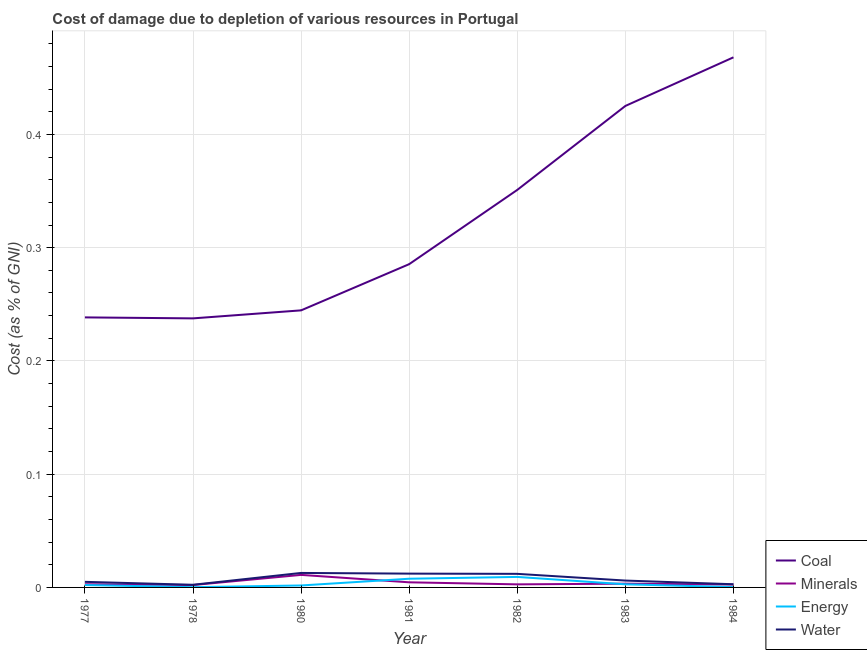How many different coloured lines are there?
Your response must be concise. 4. Does the line corresponding to cost of damage due to depletion of coal intersect with the line corresponding to cost of damage due to depletion of water?
Your answer should be very brief. No. What is the cost of damage due to depletion of minerals in 1983?
Ensure brevity in your answer.  0. Across all years, what is the maximum cost of damage due to depletion of energy?
Give a very brief answer. 0.01. Across all years, what is the minimum cost of damage due to depletion of water?
Offer a very short reply. 0. In which year was the cost of damage due to depletion of minerals minimum?
Provide a short and direct response. 1978. What is the total cost of damage due to depletion of minerals in the graph?
Your answer should be very brief. 0.03. What is the difference between the cost of damage due to depletion of coal in 1980 and that in 1981?
Ensure brevity in your answer.  -0.04. What is the difference between the cost of damage due to depletion of water in 1984 and the cost of damage due to depletion of energy in 1983?
Give a very brief answer. 5.863535926893017e-5. What is the average cost of damage due to depletion of energy per year?
Offer a very short reply. 0. In the year 1982, what is the difference between the cost of damage due to depletion of water and cost of damage due to depletion of minerals?
Ensure brevity in your answer.  0.01. In how many years, is the cost of damage due to depletion of coal greater than 0.22 %?
Keep it short and to the point. 7. What is the ratio of the cost of damage due to depletion of minerals in 1982 to that in 1984?
Your answer should be compact. 1.07. Is the difference between the cost of damage due to depletion of minerals in 1982 and 1984 greater than the difference between the cost of damage due to depletion of water in 1982 and 1984?
Provide a short and direct response. No. What is the difference between the highest and the second highest cost of damage due to depletion of minerals?
Provide a succinct answer. 0.01. What is the difference between the highest and the lowest cost of damage due to depletion of minerals?
Your answer should be compact. 0.01. Is it the case that in every year, the sum of the cost of damage due to depletion of coal and cost of damage due to depletion of minerals is greater than the cost of damage due to depletion of energy?
Make the answer very short. Yes. Does the cost of damage due to depletion of coal monotonically increase over the years?
Give a very brief answer. No. What is the difference between two consecutive major ticks on the Y-axis?
Provide a succinct answer. 0.1. Are the values on the major ticks of Y-axis written in scientific E-notation?
Your answer should be very brief. No. Does the graph contain any zero values?
Offer a very short reply. No. Where does the legend appear in the graph?
Ensure brevity in your answer.  Bottom right. What is the title of the graph?
Offer a very short reply. Cost of damage due to depletion of various resources in Portugal . What is the label or title of the Y-axis?
Ensure brevity in your answer.  Cost (as % of GNI). What is the Cost (as % of GNI) in Coal in 1977?
Ensure brevity in your answer.  0.24. What is the Cost (as % of GNI) in Minerals in 1977?
Your answer should be compact. 0. What is the Cost (as % of GNI) of Energy in 1977?
Your answer should be compact. 0. What is the Cost (as % of GNI) in Water in 1977?
Your answer should be compact. 0. What is the Cost (as % of GNI) in Coal in 1978?
Your response must be concise. 0.24. What is the Cost (as % of GNI) of Minerals in 1978?
Your answer should be very brief. 0. What is the Cost (as % of GNI) of Energy in 1978?
Provide a succinct answer. 0. What is the Cost (as % of GNI) of Water in 1978?
Provide a short and direct response. 0. What is the Cost (as % of GNI) in Coal in 1980?
Give a very brief answer. 0.24. What is the Cost (as % of GNI) in Minerals in 1980?
Provide a short and direct response. 0.01. What is the Cost (as % of GNI) in Energy in 1980?
Your answer should be very brief. 0. What is the Cost (as % of GNI) in Water in 1980?
Give a very brief answer. 0.01. What is the Cost (as % of GNI) of Coal in 1981?
Make the answer very short. 0.29. What is the Cost (as % of GNI) of Minerals in 1981?
Your answer should be very brief. 0. What is the Cost (as % of GNI) of Energy in 1981?
Your answer should be very brief. 0.01. What is the Cost (as % of GNI) in Water in 1981?
Offer a terse response. 0.01. What is the Cost (as % of GNI) of Coal in 1982?
Provide a short and direct response. 0.35. What is the Cost (as % of GNI) in Minerals in 1982?
Your response must be concise. 0. What is the Cost (as % of GNI) of Energy in 1982?
Give a very brief answer. 0.01. What is the Cost (as % of GNI) of Water in 1982?
Your answer should be compact. 0.01. What is the Cost (as % of GNI) in Coal in 1983?
Make the answer very short. 0.43. What is the Cost (as % of GNI) of Minerals in 1983?
Provide a short and direct response. 0. What is the Cost (as % of GNI) in Energy in 1983?
Provide a succinct answer. 0. What is the Cost (as % of GNI) in Water in 1983?
Offer a terse response. 0.01. What is the Cost (as % of GNI) in Coal in 1984?
Your answer should be compact. 0.47. What is the Cost (as % of GNI) in Minerals in 1984?
Your answer should be compact. 0. What is the Cost (as % of GNI) of Energy in 1984?
Your answer should be very brief. 0. What is the Cost (as % of GNI) in Water in 1984?
Keep it short and to the point. 0. Across all years, what is the maximum Cost (as % of GNI) of Coal?
Your answer should be compact. 0.47. Across all years, what is the maximum Cost (as % of GNI) of Minerals?
Provide a succinct answer. 0.01. Across all years, what is the maximum Cost (as % of GNI) in Energy?
Provide a succinct answer. 0.01. Across all years, what is the maximum Cost (as % of GNI) in Water?
Provide a short and direct response. 0.01. Across all years, what is the minimum Cost (as % of GNI) of Coal?
Make the answer very short. 0.24. Across all years, what is the minimum Cost (as % of GNI) in Minerals?
Offer a terse response. 0. Across all years, what is the minimum Cost (as % of GNI) in Energy?
Make the answer very short. 0. Across all years, what is the minimum Cost (as % of GNI) of Water?
Provide a succinct answer. 0. What is the total Cost (as % of GNI) of Coal in the graph?
Keep it short and to the point. 2.25. What is the total Cost (as % of GNI) in Minerals in the graph?
Keep it short and to the point. 0.03. What is the total Cost (as % of GNI) in Energy in the graph?
Your response must be concise. 0.02. What is the total Cost (as % of GNI) of Water in the graph?
Offer a very short reply. 0.05. What is the difference between the Cost (as % of GNI) in Coal in 1977 and that in 1978?
Your response must be concise. 0. What is the difference between the Cost (as % of GNI) of Minerals in 1977 and that in 1978?
Keep it short and to the point. 0. What is the difference between the Cost (as % of GNI) of Energy in 1977 and that in 1978?
Your answer should be very brief. 0. What is the difference between the Cost (as % of GNI) in Water in 1977 and that in 1978?
Give a very brief answer. 0. What is the difference between the Cost (as % of GNI) of Coal in 1977 and that in 1980?
Your answer should be very brief. -0.01. What is the difference between the Cost (as % of GNI) of Minerals in 1977 and that in 1980?
Your answer should be compact. -0.01. What is the difference between the Cost (as % of GNI) in Energy in 1977 and that in 1980?
Ensure brevity in your answer.  0. What is the difference between the Cost (as % of GNI) of Water in 1977 and that in 1980?
Your response must be concise. -0.01. What is the difference between the Cost (as % of GNI) in Coal in 1977 and that in 1981?
Make the answer very short. -0.05. What is the difference between the Cost (as % of GNI) in Minerals in 1977 and that in 1981?
Offer a terse response. -0. What is the difference between the Cost (as % of GNI) of Energy in 1977 and that in 1981?
Ensure brevity in your answer.  -0.01. What is the difference between the Cost (as % of GNI) of Water in 1977 and that in 1981?
Give a very brief answer. -0.01. What is the difference between the Cost (as % of GNI) of Coal in 1977 and that in 1982?
Provide a succinct answer. -0.11. What is the difference between the Cost (as % of GNI) of Minerals in 1977 and that in 1982?
Keep it short and to the point. 0. What is the difference between the Cost (as % of GNI) of Energy in 1977 and that in 1982?
Your answer should be compact. -0.01. What is the difference between the Cost (as % of GNI) in Water in 1977 and that in 1982?
Your answer should be compact. -0.01. What is the difference between the Cost (as % of GNI) in Coal in 1977 and that in 1983?
Provide a short and direct response. -0.19. What is the difference between the Cost (as % of GNI) of Minerals in 1977 and that in 1983?
Your response must be concise. -0. What is the difference between the Cost (as % of GNI) in Energy in 1977 and that in 1983?
Give a very brief answer. -0. What is the difference between the Cost (as % of GNI) in Water in 1977 and that in 1983?
Offer a very short reply. -0. What is the difference between the Cost (as % of GNI) of Coal in 1977 and that in 1984?
Your answer should be very brief. -0.23. What is the difference between the Cost (as % of GNI) in Energy in 1977 and that in 1984?
Provide a succinct answer. 0. What is the difference between the Cost (as % of GNI) in Water in 1977 and that in 1984?
Provide a short and direct response. 0. What is the difference between the Cost (as % of GNI) of Coal in 1978 and that in 1980?
Make the answer very short. -0.01. What is the difference between the Cost (as % of GNI) in Minerals in 1978 and that in 1980?
Give a very brief answer. -0.01. What is the difference between the Cost (as % of GNI) of Energy in 1978 and that in 1980?
Provide a short and direct response. -0. What is the difference between the Cost (as % of GNI) of Water in 1978 and that in 1980?
Give a very brief answer. -0.01. What is the difference between the Cost (as % of GNI) of Coal in 1978 and that in 1981?
Offer a terse response. -0.05. What is the difference between the Cost (as % of GNI) of Minerals in 1978 and that in 1981?
Make the answer very short. -0. What is the difference between the Cost (as % of GNI) in Energy in 1978 and that in 1981?
Your response must be concise. -0.01. What is the difference between the Cost (as % of GNI) of Water in 1978 and that in 1981?
Make the answer very short. -0.01. What is the difference between the Cost (as % of GNI) of Coal in 1978 and that in 1982?
Your answer should be very brief. -0.11. What is the difference between the Cost (as % of GNI) in Minerals in 1978 and that in 1982?
Provide a succinct answer. -0. What is the difference between the Cost (as % of GNI) of Energy in 1978 and that in 1982?
Offer a terse response. -0.01. What is the difference between the Cost (as % of GNI) in Water in 1978 and that in 1982?
Make the answer very short. -0.01. What is the difference between the Cost (as % of GNI) of Coal in 1978 and that in 1983?
Offer a very short reply. -0.19. What is the difference between the Cost (as % of GNI) in Minerals in 1978 and that in 1983?
Offer a terse response. -0. What is the difference between the Cost (as % of GNI) of Energy in 1978 and that in 1983?
Give a very brief answer. -0. What is the difference between the Cost (as % of GNI) in Water in 1978 and that in 1983?
Provide a short and direct response. -0. What is the difference between the Cost (as % of GNI) in Coal in 1978 and that in 1984?
Give a very brief answer. -0.23. What is the difference between the Cost (as % of GNI) of Minerals in 1978 and that in 1984?
Keep it short and to the point. -0. What is the difference between the Cost (as % of GNI) in Energy in 1978 and that in 1984?
Keep it short and to the point. -0. What is the difference between the Cost (as % of GNI) of Water in 1978 and that in 1984?
Offer a very short reply. -0. What is the difference between the Cost (as % of GNI) in Coal in 1980 and that in 1981?
Ensure brevity in your answer.  -0.04. What is the difference between the Cost (as % of GNI) in Minerals in 1980 and that in 1981?
Make the answer very short. 0.01. What is the difference between the Cost (as % of GNI) of Energy in 1980 and that in 1981?
Give a very brief answer. -0.01. What is the difference between the Cost (as % of GNI) of Water in 1980 and that in 1981?
Provide a short and direct response. 0. What is the difference between the Cost (as % of GNI) in Coal in 1980 and that in 1982?
Make the answer very short. -0.11. What is the difference between the Cost (as % of GNI) of Minerals in 1980 and that in 1982?
Provide a succinct answer. 0.01. What is the difference between the Cost (as % of GNI) in Energy in 1980 and that in 1982?
Provide a succinct answer. -0.01. What is the difference between the Cost (as % of GNI) in Water in 1980 and that in 1982?
Make the answer very short. 0. What is the difference between the Cost (as % of GNI) in Coal in 1980 and that in 1983?
Give a very brief answer. -0.18. What is the difference between the Cost (as % of GNI) in Minerals in 1980 and that in 1983?
Offer a terse response. 0.01. What is the difference between the Cost (as % of GNI) of Energy in 1980 and that in 1983?
Your response must be concise. -0. What is the difference between the Cost (as % of GNI) in Water in 1980 and that in 1983?
Keep it short and to the point. 0.01. What is the difference between the Cost (as % of GNI) in Coal in 1980 and that in 1984?
Offer a very short reply. -0.22. What is the difference between the Cost (as % of GNI) of Minerals in 1980 and that in 1984?
Offer a very short reply. 0.01. What is the difference between the Cost (as % of GNI) in Energy in 1980 and that in 1984?
Provide a succinct answer. 0. What is the difference between the Cost (as % of GNI) in Water in 1980 and that in 1984?
Keep it short and to the point. 0.01. What is the difference between the Cost (as % of GNI) of Coal in 1981 and that in 1982?
Your answer should be very brief. -0.07. What is the difference between the Cost (as % of GNI) in Minerals in 1981 and that in 1982?
Your answer should be compact. 0. What is the difference between the Cost (as % of GNI) in Energy in 1981 and that in 1982?
Your answer should be compact. -0. What is the difference between the Cost (as % of GNI) in Coal in 1981 and that in 1983?
Give a very brief answer. -0.14. What is the difference between the Cost (as % of GNI) of Minerals in 1981 and that in 1983?
Provide a succinct answer. 0. What is the difference between the Cost (as % of GNI) of Energy in 1981 and that in 1983?
Make the answer very short. 0. What is the difference between the Cost (as % of GNI) in Water in 1981 and that in 1983?
Make the answer very short. 0.01. What is the difference between the Cost (as % of GNI) in Coal in 1981 and that in 1984?
Provide a succinct answer. -0.18. What is the difference between the Cost (as % of GNI) in Minerals in 1981 and that in 1984?
Your answer should be compact. 0. What is the difference between the Cost (as % of GNI) in Energy in 1981 and that in 1984?
Make the answer very short. 0.01. What is the difference between the Cost (as % of GNI) of Water in 1981 and that in 1984?
Provide a short and direct response. 0.01. What is the difference between the Cost (as % of GNI) of Coal in 1982 and that in 1983?
Your answer should be very brief. -0.07. What is the difference between the Cost (as % of GNI) in Minerals in 1982 and that in 1983?
Your answer should be compact. -0. What is the difference between the Cost (as % of GNI) in Energy in 1982 and that in 1983?
Provide a short and direct response. 0.01. What is the difference between the Cost (as % of GNI) of Water in 1982 and that in 1983?
Give a very brief answer. 0.01. What is the difference between the Cost (as % of GNI) of Coal in 1982 and that in 1984?
Offer a very short reply. -0.12. What is the difference between the Cost (as % of GNI) in Minerals in 1982 and that in 1984?
Keep it short and to the point. 0. What is the difference between the Cost (as % of GNI) of Energy in 1982 and that in 1984?
Your answer should be very brief. 0.01. What is the difference between the Cost (as % of GNI) in Water in 1982 and that in 1984?
Make the answer very short. 0.01. What is the difference between the Cost (as % of GNI) in Coal in 1983 and that in 1984?
Offer a terse response. -0.04. What is the difference between the Cost (as % of GNI) of Minerals in 1983 and that in 1984?
Your answer should be very brief. 0. What is the difference between the Cost (as % of GNI) in Energy in 1983 and that in 1984?
Your answer should be compact. 0. What is the difference between the Cost (as % of GNI) in Water in 1983 and that in 1984?
Ensure brevity in your answer.  0. What is the difference between the Cost (as % of GNI) in Coal in 1977 and the Cost (as % of GNI) in Minerals in 1978?
Your answer should be compact. 0.24. What is the difference between the Cost (as % of GNI) in Coal in 1977 and the Cost (as % of GNI) in Energy in 1978?
Your answer should be very brief. 0.24. What is the difference between the Cost (as % of GNI) in Coal in 1977 and the Cost (as % of GNI) in Water in 1978?
Provide a succinct answer. 0.24. What is the difference between the Cost (as % of GNI) of Minerals in 1977 and the Cost (as % of GNI) of Energy in 1978?
Ensure brevity in your answer.  0. What is the difference between the Cost (as % of GNI) of Minerals in 1977 and the Cost (as % of GNI) of Water in 1978?
Offer a very short reply. 0. What is the difference between the Cost (as % of GNI) in Energy in 1977 and the Cost (as % of GNI) in Water in 1978?
Provide a short and direct response. -0. What is the difference between the Cost (as % of GNI) in Coal in 1977 and the Cost (as % of GNI) in Minerals in 1980?
Ensure brevity in your answer.  0.23. What is the difference between the Cost (as % of GNI) in Coal in 1977 and the Cost (as % of GNI) in Energy in 1980?
Keep it short and to the point. 0.24. What is the difference between the Cost (as % of GNI) in Coal in 1977 and the Cost (as % of GNI) in Water in 1980?
Your response must be concise. 0.23. What is the difference between the Cost (as % of GNI) of Minerals in 1977 and the Cost (as % of GNI) of Energy in 1980?
Your answer should be very brief. 0. What is the difference between the Cost (as % of GNI) in Minerals in 1977 and the Cost (as % of GNI) in Water in 1980?
Give a very brief answer. -0.01. What is the difference between the Cost (as % of GNI) in Energy in 1977 and the Cost (as % of GNI) in Water in 1980?
Provide a short and direct response. -0.01. What is the difference between the Cost (as % of GNI) of Coal in 1977 and the Cost (as % of GNI) of Minerals in 1981?
Provide a short and direct response. 0.23. What is the difference between the Cost (as % of GNI) in Coal in 1977 and the Cost (as % of GNI) in Energy in 1981?
Keep it short and to the point. 0.23. What is the difference between the Cost (as % of GNI) in Coal in 1977 and the Cost (as % of GNI) in Water in 1981?
Give a very brief answer. 0.23. What is the difference between the Cost (as % of GNI) of Minerals in 1977 and the Cost (as % of GNI) of Energy in 1981?
Provide a succinct answer. -0. What is the difference between the Cost (as % of GNI) of Minerals in 1977 and the Cost (as % of GNI) of Water in 1981?
Ensure brevity in your answer.  -0.01. What is the difference between the Cost (as % of GNI) in Energy in 1977 and the Cost (as % of GNI) in Water in 1981?
Your answer should be compact. -0.01. What is the difference between the Cost (as % of GNI) of Coal in 1977 and the Cost (as % of GNI) of Minerals in 1982?
Keep it short and to the point. 0.24. What is the difference between the Cost (as % of GNI) in Coal in 1977 and the Cost (as % of GNI) in Energy in 1982?
Keep it short and to the point. 0.23. What is the difference between the Cost (as % of GNI) of Coal in 1977 and the Cost (as % of GNI) of Water in 1982?
Provide a succinct answer. 0.23. What is the difference between the Cost (as % of GNI) in Minerals in 1977 and the Cost (as % of GNI) in Energy in 1982?
Offer a terse response. -0.01. What is the difference between the Cost (as % of GNI) in Minerals in 1977 and the Cost (as % of GNI) in Water in 1982?
Give a very brief answer. -0.01. What is the difference between the Cost (as % of GNI) of Energy in 1977 and the Cost (as % of GNI) of Water in 1982?
Your answer should be very brief. -0.01. What is the difference between the Cost (as % of GNI) in Coal in 1977 and the Cost (as % of GNI) in Minerals in 1983?
Your answer should be very brief. 0.24. What is the difference between the Cost (as % of GNI) in Coal in 1977 and the Cost (as % of GNI) in Energy in 1983?
Give a very brief answer. 0.24. What is the difference between the Cost (as % of GNI) in Coal in 1977 and the Cost (as % of GNI) in Water in 1983?
Provide a succinct answer. 0.23. What is the difference between the Cost (as % of GNI) in Minerals in 1977 and the Cost (as % of GNI) in Water in 1983?
Ensure brevity in your answer.  -0. What is the difference between the Cost (as % of GNI) of Energy in 1977 and the Cost (as % of GNI) of Water in 1983?
Keep it short and to the point. -0. What is the difference between the Cost (as % of GNI) of Coal in 1977 and the Cost (as % of GNI) of Minerals in 1984?
Provide a succinct answer. 0.24. What is the difference between the Cost (as % of GNI) of Coal in 1977 and the Cost (as % of GNI) of Energy in 1984?
Provide a short and direct response. 0.24. What is the difference between the Cost (as % of GNI) of Coal in 1977 and the Cost (as % of GNI) of Water in 1984?
Keep it short and to the point. 0.24. What is the difference between the Cost (as % of GNI) in Minerals in 1977 and the Cost (as % of GNI) in Energy in 1984?
Your answer should be very brief. 0. What is the difference between the Cost (as % of GNI) in Energy in 1977 and the Cost (as % of GNI) in Water in 1984?
Offer a terse response. -0. What is the difference between the Cost (as % of GNI) in Coal in 1978 and the Cost (as % of GNI) in Minerals in 1980?
Your answer should be compact. 0.23. What is the difference between the Cost (as % of GNI) of Coal in 1978 and the Cost (as % of GNI) of Energy in 1980?
Give a very brief answer. 0.24. What is the difference between the Cost (as % of GNI) in Coal in 1978 and the Cost (as % of GNI) in Water in 1980?
Provide a short and direct response. 0.22. What is the difference between the Cost (as % of GNI) of Minerals in 1978 and the Cost (as % of GNI) of Energy in 1980?
Provide a short and direct response. 0. What is the difference between the Cost (as % of GNI) in Minerals in 1978 and the Cost (as % of GNI) in Water in 1980?
Make the answer very short. -0.01. What is the difference between the Cost (as % of GNI) of Energy in 1978 and the Cost (as % of GNI) of Water in 1980?
Make the answer very short. -0.01. What is the difference between the Cost (as % of GNI) in Coal in 1978 and the Cost (as % of GNI) in Minerals in 1981?
Keep it short and to the point. 0.23. What is the difference between the Cost (as % of GNI) in Coal in 1978 and the Cost (as % of GNI) in Energy in 1981?
Your answer should be very brief. 0.23. What is the difference between the Cost (as % of GNI) in Coal in 1978 and the Cost (as % of GNI) in Water in 1981?
Give a very brief answer. 0.23. What is the difference between the Cost (as % of GNI) in Minerals in 1978 and the Cost (as % of GNI) in Energy in 1981?
Your answer should be compact. -0.01. What is the difference between the Cost (as % of GNI) in Minerals in 1978 and the Cost (as % of GNI) in Water in 1981?
Your response must be concise. -0.01. What is the difference between the Cost (as % of GNI) of Energy in 1978 and the Cost (as % of GNI) of Water in 1981?
Your answer should be very brief. -0.01. What is the difference between the Cost (as % of GNI) of Coal in 1978 and the Cost (as % of GNI) of Minerals in 1982?
Ensure brevity in your answer.  0.23. What is the difference between the Cost (as % of GNI) of Coal in 1978 and the Cost (as % of GNI) of Energy in 1982?
Provide a succinct answer. 0.23. What is the difference between the Cost (as % of GNI) in Coal in 1978 and the Cost (as % of GNI) in Water in 1982?
Make the answer very short. 0.23. What is the difference between the Cost (as % of GNI) in Minerals in 1978 and the Cost (as % of GNI) in Energy in 1982?
Your response must be concise. -0.01. What is the difference between the Cost (as % of GNI) in Minerals in 1978 and the Cost (as % of GNI) in Water in 1982?
Make the answer very short. -0.01. What is the difference between the Cost (as % of GNI) in Energy in 1978 and the Cost (as % of GNI) in Water in 1982?
Keep it short and to the point. -0.01. What is the difference between the Cost (as % of GNI) in Coal in 1978 and the Cost (as % of GNI) in Minerals in 1983?
Your response must be concise. 0.23. What is the difference between the Cost (as % of GNI) in Coal in 1978 and the Cost (as % of GNI) in Energy in 1983?
Provide a succinct answer. 0.23. What is the difference between the Cost (as % of GNI) of Coal in 1978 and the Cost (as % of GNI) of Water in 1983?
Your answer should be compact. 0.23. What is the difference between the Cost (as % of GNI) of Minerals in 1978 and the Cost (as % of GNI) of Energy in 1983?
Give a very brief answer. -0. What is the difference between the Cost (as % of GNI) in Minerals in 1978 and the Cost (as % of GNI) in Water in 1983?
Keep it short and to the point. -0. What is the difference between the Cost (as % of GNI) in Energy in 1978 and the Cost (as % of GNI) in Water in 1983?
Give a very brief answer. -0.01. What is the difference between the Cost (as % of GNI) of Coal in 1978 and the Cost (as % of GNI) of Minerals in 1984?
Your answer should be very brief. 0.23. What is the difference between the Cost (as % of GNI) in Coal in 1978 and the Cost (as % of GNI) in Energy in 1984?
Make the answer very short. 0.24. What is the difference between the Cost (as % of GNI) in Coal in 1978 and the Cost (as % of GNI) in Water in 1984?
Keep it short and to the point. 0.23. What is the difference between the Cost (as % of GNI) in Minerals in 1978 and the Cost (as % of GNI) in Energy in 1984?
Your answer should be compact. 0. What is the difference between the Cost (as % of GNI) in Minerals in 1978 and the Cost (as % of GNI) in Water in 1984?
Ensure brevity in your answer.  -0. What is the difference between the Cost (as % of GNI) of Energy in 1978 and the Cost (as % of GNI) of Water in 1984?
Provide a succinct answer. -0. What is the difference between the Cost (as % of GNI) of Coal in 1980 and the Cost (as % of GNI) of Minerals in 1981?
Provide a short and direct response. 0.24. What is the difference between the Cost (as % of GNI) of Coal in 1980 and the Cost (as % of GNI) of Energy in 1981?
Provide a succinct answer. 0.24. What is the difference between the Cost (as % of GNI) of Coal in 1980 and the Cost (as % of GNI) of Water in 1981?
Provide a succinct answer. 0.23. What is the difference between the Cost (as % of GNI) of Minerals in 1980 and the Cost (as % of GNI) of Energy in 1981?
Your answer should be compact. 0. What is the difference between the Cost (as % of GNI) of Minerals in 1980 and the Cost (as % of GNI) of Water in 1981?
Your response must be concise. -0. What is the difference between the Cost (as % of GNI) of Energy in 1980 and the Cost (as % of GNI) of Water in 1981?
Make the answer very short. -0.01. What is the difference between the Cost (as % of GNI) of Coal in 1980 and the Cost (as % of GNI) of Minerals in 1982?
Offer a very short reply. 0.24. What is the difference between the Cost (as % of GNI) of Coal in 1980 and the Cost (as % of GNI) of Energy in 1982?
Keep it short and to the point. 0.24. What is the difference between the Cost (as % of GNI) of Coal in 1980 and the Cost (as % of GNI) of Water in 1982?
Your answer should be very brief. 0.23. What is the difference between the Cost (as % of GNI) in Minerals in 1980 and the Cost (as % of GNI) in Energy in 1982?
Your answer should be very brief. 0. What is the difference between the Cost (as % of GNI) in Minerals in 1980 and the Cost (as % of GNI) in Water in 1982?
Your answer should be very brief. -0. What is the difference between the Cost (as % of GNI) in Energy in 1980 and the Cost (as % of GNI) in Water in 1982?
Ensure brevity in your answer.  -0.01. What is the difference between the Cost (as % of GNI) of Coal in 1980 and the Cost (as % of GNI) of Minerals in 1983?
Ensure brevity in your answer.  0.24. What is the difference between the Cost (as % of GNI) of Coal in 1980 and the Cost (as % of GNI) of Energy in 1983?
Offer a very short reply. 0.24. What is the difference between the Cost (as % of GNI) of Coal in 1980 and the Cost (as % of GNI) of Water in 1983?
Your response must be concise. 0.24. What is the difference between the Cost (as % of GNI) of Minerals in 1980 and the Cost (as % of GNI) of Energy in 1983?
Offer a terse response. 0.01. What is the difference between the Cost (as % of GNI) of Minerals in 1980 and the Cost (as % of GNI) of Water in 1983?
Give a very brief answer. 0.01. What is the difference between the Cost (as % of GNI) of Energy in 1980 and the Cost (as % of GNI) of Water in 1983?
Keep it short and to the point. -0. What is the difference between the Cost (as % of GNI) in Coal in 1980 and the Cost (as % of GNI) in Minerals in 1984?
Ensure brevity in your answer.  0.24. What is the difference between the Cost (as % of GNI) in Coal in 1980 and the Cost (as % of GNI) in Energy in 1984?
Your answer should be very brief. 0.24. What is the difference between the Cost (as % of GNI) in Coal in 1980 and the Cost (as % of GNI) in Water in 1984?
Keep it short and to the point. 0.24. What is the difference between the Cost (as % of GNI) of Minerals in 1980 and the Cost (as % of GNI) of Energy in 1984?
Give a very brief answer. 0.01. What is the difference between the Cost (as % of GNI) in Minerals in 1980 and the Cost (as % of GNI) in Water in 1984?
Provide a succinct answer. 0.01. What is the difference between the Cost (as % of GNI) of Energy in 1980 and the Cost (as % of GNI) of Water in 1984?
Your response must be concise. -0. What is the difference between the Cost (as % of GNI) of Coal in 1981 and the Cost (as % of GNI) of Minerals in 1982?
Your answer should be very brief. 0.28. What is the difference between the Cost (as % of GNI) of Coal in 1981 and the Cost (as % of GNI) of Energy in 1982?
Provide a short and direct response. 0.28. What is the difference between the Cost (as % of GNI) of Coal in 1981 and the Cost (as % of GNI) of Water in 1982?
Make the answer very short. 0.27. What is the difference between the Cost (as % of GNI) of Minerals in 1981 and the Cost (as % of GNI) of Energy in 1982?
Your answer should be compact. -0. What is the difference between the Cost (as % of GNI) in Minerals in 1981 and the Cost (as % of GNI) in Water in 1982?
Keep it short and to the point. -0.01. What is the difference between the Cost (as % of GNI) in Energy in 1981 and the Cost (as % of GNI) in Water in 1982?
Give a very brief answer. -0. What is the difference between the Cost (as % of GNI) of Coal in 1981 and the Cost (as % of GNI) of Minerals in 1983?
Provide a short and direct response. 0.28. What is the difference between the Cost (as % of GNI) of Coal in 1981 and the Cost (as % of GNI) of Energy in 1983?
Provide a succinct answer. 0.28. What is the difference between the Cost (as % of GNI) of Coal in 1981 and the Cost (as % of GNI) of Water in 1983?
Ensure brevity in your answer.  0.28. What is the difference between the Cost (as % of GNI) in Minerals in 1981 and the Cost (as % of GNI) in Energy in 1983?
Your answer should be very brief. 0. What is the difference between the Cost (as % of GNI) of Minerals in 1981 and the Cost (as % of GNI) of Water in 1983?
Make the answer very short. -0. What is the difference between the Cost (as % of GNI) in Energy in 1981 and the Cost (as % of GNI) in Water in 1983?
Keep it short and to the point. 0. What is the difference between the Cost (as % of GNI) in Coal in 1981 and the Cost (as % of GNI) in Minerals in 1984?
Make the answer very short. 0.28. What is the difference between the Cost (as % of GNI) of Coal in 1981 and the Cost (as % of GNI) of Energy in 1984?
Offer a very short reply. 0.29. What is the difference between the Cost (as % of GNI) of Coal in 1981 and the Cost (as % of GNI) of Water in 1984?
Make the answer very short. 0.28. What is the difference between the Cost (as % of GNI) of Minerals in 1981 and the Cost (as % of GNI) of Energy in 1984?
Ensure brevity in your answer.  0. What is the difference between the Cost (as % of GNI) of Minerals in 1981 and the Cost (as % of GNI) of Water in 1984?
Your answer should be very brief. 0. What is the difference between the Cost (as % of GNI) in Energy in 1981 and the Cost (as % of GNI) in Water in 1984?
Your answer should be very brief. 0. What is the difference between the Cost (as % of GNI) of Coal in 1982 and the Cost (as % of GNI) of Minerals in 1983?
Ensure brevity in your answer.  0.35. What is the difference between the Cost (as % of GNI) in Coal in 1982 and the Cost (as % of GNI) in Energy in 1983?
Give a very brief answer. 0.35. What is the difference between the Cost (as % of GNI) of Coal in 1982 and the Cost (as % of GNI) of Water in 1983?
Keep it short and to the point. 0.34. What is the difference between the Cost (as % of GNI) in Minerals in 1982 and the Cost (as % of GNI) in Energy in 1983?
Provide a succinct answer. -0. What is the difference between the Cost (as % of GNI) in Minerals in 1982 and the Cost (as % of GNI) in Water in 1983?
Offer a terse response. -0. What is the difference between the Cost (as % of GNI) of Energy in 1982 and the Cost (as % of GNI) of Water in 1983?
Provide a succinct answer. 0. What is the difference between the Cost (as % of GNI) in Coal in 1982 and the Cost (as % of GNI) in Minerals in 1984?
Ensure brevity in your answer.  0.35. What is the difference between the Cost (as % of GNI) in Coal in 1982 and the Cost (as % of GNI) in Energy in 1984?
Your answer should be very brief. 0.35. What is the difference between the Cost (as % of GNI) of Coal in 1982 and the Cost (as % of GNI) of Water in 1984?
Offer a very short reply. 0.35. What is the difference between the Cost (as % of GNI) in Minerals in 1982 and the Cost (as % of GNI) in Energy in 1984?
Give a very brief answer. 0. What is the difference between the Cost (as % of GNI) in Minerals in 1982 and the Cost (as % of GNI) in Water in 1984?
Ensure brevity in your answer.  -0. What is the difference between the Cost (as % of GNI) in Energy in 1982 and the Cost (as % of GNI) in Water in 1984?
Make the answer very short. 0.01. What is the difference between the Cost (as % of GNI) in Coal in 1983 and the Cost (as % of GNI) in Minerals in 1984?
Give a very brief answer. 0.42. What is the difference between the Cost (as % of GNI) of Coal in 1983 and the Cost (as % of GNI) of Energy in 1984?
Provide a short and direct response. 0.42. What is the difference between the Cost (as % of GNI) in Coal in 1983 and the Cost (as % of GNI) in Water in 1984?
Your answer should be compact. 0.42. What is the difference between the Cost (as % of GNI) in Minerals in 1983 and the Cost (as % of GNI) in Energy in 1984?
Provide a succinct answer. 0. What is the difference between the Cost (as % of GNI) of Minerals in 1983 and the Cost (as % of GNI) of Water in 1984?
Offer a very short reply. 0. What is the difference between the Cost (as % of GNI) in Energy in 1983 and the Cost (as % of GNI) in Water in 1984?
Offer a terse response. -0. What is the average Cost (as % of GNI) of Coal per year?
Keep it short and to the point. 0.32. What is the average Cost (as % of GNI) of Minerals per year?
Ensure brevity in your answer.  0. What is the average Cost (as % of GNI) of Energy per year?
Your response must be concise. 0. What is the average Cost (as % of GNI) in Water per year?
Your answer should be very brief. 0.01. In the year 1977, what is the difference between the Cost (as % of GNI) in Coal and Cost (as % of GNI) in Minerals?
Give a very brief answer. 0.24. In the year 1977, what is the difference between the Cost (as % of GNI) in Coal and Cost (as % of GNI) in Energy?
Your answer should be very brief. 0.24. In the year 1977, what is the difference between the Cost (as % of GNI) in Coal and Cost (as % of GNI) in Water?
Your response must be concise. 0.23. In the year 1977, what is the difference between the Cost (as % of GNI) of Minerals and Cost (as % of GNI) of Energy?
Your answer should be very brief. 0. In the year 1977, what is the difference between the Cost (as % of GNI) in Minerals and Cost (as % of GNI) in Water?
Your response must be concise. -0. In the year 1977, what is the difference between the Cost (as % of GNI) in Energy and Cost (as % of GNI) in Water?
Keep it short and to the point. -0. In the year 1978, what is the difference between the Cost (as % of GNI) in Coal and Cost (as % of GNI) in Minerals?
Provide a short and direct response. 0.24. In the year 1978, what is the difference between the Cost (as % of GNI) of Coal and Cost (as % of GNI) of Energy?
Provide a succinct answer. 0.24. In the year 1978, what is the difference between the Cost (as % of GNI) in Coal and Cost (as % of GNI) in Water?
Offer a terse response. 0.24. In the year 1978, what is the difference between the Cost (as % of GNI) of Minerals and Cost (as % of GNI) of Energy?
Your response must be concise. 0. In the year 1978, what is the difference between the Cost (as % of GNI) in Minerals and Cost (as % of GNI) in Water?
Make the answer very short. -0. In the year 1978, what is the difference between the Cost (as % of GNI) of Energy and Cost (as % of GNI) of Water?
Provide a short and direct response. -0. In the year 1980, what is the difference between the Cost (as % of GNI) of Coal and Cost (as % of GNI) of Minerals?
Provide a succinct answer. 0.23. In the year 1980, what is the difference between the Cost (as % of GNI) of Coal and Cost (as % of GNI) of Energy?
Make the answer very short. 0.24. In the year 1980, what is the difference between the Cost (as % of GNI) in Coal and Cost (as % of GNI) in Water?
Keep it short and to the point. 0.23. In the year 1980, what is the difference between the Cost (as % of GNI) in Minerals and Cost (as % of GNI) in Energy?
Provide a short and direct response. 0.01. In the year 1980, what is the difference between the Cost (as % of GNI) in Minerals and Cost (as % of GNI) in Water?
Provide a short and direct response. -0. In the year 1980, what is the difference between the Cost (as % of GNI) in Energy and Cost (as % of GNI) in Water?
Offer a very short reply. -0.01. In the year 1981, what is the difference between the Cost (as % of GNI) of Coal and Cost (as % of GNI) of Minerals?
Give a very brief answer. 0.28. In the year 1981, what is the difference between the Cost (as % of GNI) in Coal and Cost (as % of GNI) in Energy?
Keep it short and to the point. 0.28. In the year 1981, what is the difference between the Cost (as % of GNI) in Coal and Cost (as % of GNI) in Water?
Ensure brevity in your answer.  0.27. In the year 1981, what is the difference between the Cost (as % of GNI) in Minerals and Cost (as % of GNI) in Energy?
Ensure brevity in your answer.  -0. In the year 1981, what is the difference between the Cost (as % of GNI) in Minerals and Cost (as % of GNI) in Water?
Give a very brief answer. -0.01. In the year 1981, what is the difference between the Cost (as % of GNI) of Energy and Cost (as % of GNI) of Water?
Your answer should be very brief. -0. In the year 1982, what is the difference between the Cost (as % of GNI) in Coal and Cost (as % of GNI) in Minerals?
Ensure brevity in your answer.  0.35. In the year 1982, what is the difference between the Cost (as % of GNI) in Coal and Cost (as % of GNI) in Energy?
Offer a terse response. 0.34. In the year 1982, what is the difference between the Cost (as % of GNI) in Coal and Cost (as % of GNI) in Water?
Provide a short and direct response. 0.34. In the year 1982, what is the difference between the Cost (as % of GNI) of Minerals and Cost (as % of GNI) of Energy?
Your response must be concise. -0.01. In the year 1982, what is the difference between the Cost (as % of GNI) of Minerals and Cost (as % of GNI) of Water?
Offer a very short reply. -0.01. In the year 1982, what is the difference between the Cost (as % of GNI) of Energy and Cost (as % of GNI) of Water?
Provide a short and direct response. -0. In the year 1983, what is the difference between the Cost (as % of GNI) in Coal and Cost (as % of GNI) in Minerals?
Ensure brevity in your answer.  0.42. In the year 1983, what is the difference between the Cost (as % of GNI) of Coal and Cost (as % of GNI) of Energy?
Keep it short and to the point. 0.42. In the year 1983, what is the difference between the Cost (as % of GNI) of Coal and Cost (as % of GNI) of Water?
Keep it short and to the point. 0.42. In the year 1983, what is the difference between the Cost (as % of GNI) of Minerals and Cost (as % of GNI) of Energy?
Your answer should be compact. 0. In the year 1983, what is the difference between the Cost (as % of GNI) of Minerals and Cost (as % of GNI) of Water?
Give a very brief answer. -0. In the year 1983, what is the difference between the Cost (as % of GNI) in Energy and Cost (as % of GNI) in Water?
Give a very brief answer. -0. In the year 1984, what is the difference between the Cost (as % of GNI) in Coal and Cost (as % of GNI) in Minerals?
Provide a succinct answer. 0.47. In the year 1984, what is the difference between the Cost (as % of GNI) of Coal and Cost (as % of GNI) of Energy?
Your answer should be compact. 0.47. In the year 1984, what is the difference between the Cost (as % of GNI) of Coal and Cost (as % of GNI) of Water?
Keep it short and to the point. 0.47. In the year 1984, what is the difference between the Cost (as % of GNI) of Minerals and Cost (as % of GNI) of Energy?
Keep it short and to the point. 0. In the year 1984, what is the difference between the Cost (as % of GNI) in Minerals and Cost (as % of GNI) in Water?
Your answer should be compact. -0. In the year 1984, what is the difference between the Cost (as % of GNI) of Energy and Cost (as % of GNI) of Water?
Provide a succinct answer. -0. What is the ratio of the Cost (as % of GNI) of Minerals in 1977 to that in 1978?
Give a very brief answer. 1.32. What is the ratio of the Cost (as % of GNI) in Energy in 1977 to that in 1978?
Give a very brief answer. 9.55. What is the ratio of the Cost (as % of GNI) of Water in 1977 to that in 1978?
Make the answer very short. 2.11. What is the ratio of the Cost (as % of GNI) in Coal in 1977 to that in 1980?
Give a very brief answer. 0.97. What is the ratio of the Cost (as % of GNI) of Minerals in 1977 to that in 1980?
Provide a short and direct response. 0.25. What is the ratio of the Cost (as % of GNI) in Energy in 1977 to that in 1980?
Your response must be concise. 1.23. What is the ratio of the Cost (as % of GNI) of Water in 1977 to that in 1980?
Make the answer very short. 0.39. What is the ratio of the Cost (as % of GNI) in Coal in 1977 to that in 1981?
Your response must be concise. 0.84. What is the ratio of the Cost (as % of GNI) in Minerals in 1977 to that in 1981?
Ensure brevity in your answer.  0.62. What is the ratio of the Cost (as % of GNI) of Energy in 1977 to that in 1981?
Provide a succinct answer. 0.28. What is the ratio of the Cost (as % of GNI) in Water in 1977 to that in 1981?
Offer a terse response. 0.4. What is the ratio of the Cost (as % of GNI) in Coal in 1977 to that in 1982?
Your answer should be very brief. 0.68. What is the ratio of the Cost (as % of GNI) in Minerals in 1977 to that in 1982?
Provide a succinct answer. 1.03. What is the ratio of the Cost (as % of GNI) of Energy in 1977 to that in 1982?
Ensure brevity in your answer.  0.23. What is the ratio of the Cost (as % of GNI) in Water in 1977 to that in 1982?
Ensure brevity in your answer.  0.41. What is the ratio of the Cost (as % of GNI) in Coal in 1977 to that in 1983?
Ensure brevity in your answer.  0.56. What is the ratio of the Cost (as % of GNI) in Minerals in 1977 to that in 1983?
Keep it short and to the point. 0.85. What is the ratio of the Cost (as % of GNI) in Energy in 1977 to that in 1983?
Your answer should be very brief. 0.77. What is the ratio of the Cost (as % of GNI) in Water in 1977 to that in 1983?
Offer a very short reply. 0.81. What is the ratio of the Cost (as % of GNI) in Coal in 1977 to that in 1984?
Your answer should be very brief. 0.51. What is the ratio of the Cost (as % of GNI) in Minerals in 1977 to that in 1984?
Your answer should be compact. 1.11. What is the ratio of the Cost (as % of GNI) of Energy in 1977 to that in 1984?
Give a very brief answer. 7.47. What is the ratio of the Cost (as % of GNI) of Water in 1977 to that in 1984?
Ensure brevity in your answer.  1.76. What is the ratio of the Cost (as % of GNI) of Coal in 1978 to that in 1980?
Your response must be concise. 0.97. What is the ratio of the Cost (as % of GNI) in Minerals in 1978 to that in 1980?
Offer a very short reply. 0.19. What is the ratio of the Cost (as % of GNI) in Energy in 1978 to that in 1980?
Provide a short and direct response. 0.13. What is the ratio of the Cost (as % of GNI) in Water in 1978 to that in 1980?
Your response must be concise. 0.18. What is the ratio of the Cost (as % of GNI) of Coal in 1978 to that in 1981?
Your answer should be very brief. 0.83. What is the ratio of the Cost (as % of GNI) in Minerals in 1978 to that in 1981?
Offer a terse response. 0.47. What is the ratio of the Cost (as % of GNI) in Energy in 1978 to that in 1981?
Offer a terse response. 0.03. What is the ratio of the Cost (as % of GNI) in Water in 1978 to that in 1981?
Your answer should be very brief. 0.19. What is the ratio of the Cost (as % of GNI) in Coal in 1978 to that in 1982?
Your response must be concise. 0.68. What is the ratio of the Cost (as % of GNI) in Minerals in 1978 to that in 1982?
Provide a short and direct response. 0.78. What is the ratio of the Cost (as % of GNI) in Energy in 1978 to that in 1982?
Make the answer very short. 0.02. What is the ratio of the Cost (as % of GNI) of Water in 1978 to that in 1982?
Provide a short and direct response. 0.2. What is the ratio of the Cost (as % of GNI) of Coal in 1978 to that in 1983?
Keep it short and to the point. 0.56. What is the ratio of the Cost (as % of GNI) in Minerals in 1978 to that in 1983?
Give a very brief answer. 0.64. What is the ratio of the Cost (as % of GNI) of Energy in 1978 to that in 1983?
Provide a short and direct response. 0.08. What is the ratio of the Cost (as % of GNI) in Water in 1978 to that in 1983?
Your answer should be very brief. 0.39. What is the ratio of the Cost (as % of GNI) of Coal in 1978 to that in 1984?
Ensure brevity in your answer.  0.51. What is the ratio of the Cost (as % of GNI) of Minerals in 1978 to that in 1984?
Offer a very short reply. 0.84. What is the ratio of the Cost (as % of GNI) of Energy in 1978 to that in 1984?
Make the answer very short. 0.78. What is the ratio of the Cost (as % of GNI) in Water in 1978 to that in 1984?
Offer a terse response. 0.83. What is the ratio of the Cost (as % of GNI) of Minerals in 1980 to that in 1981?
Offer a terse response. 2.45. What is the ratio of the Cost (as % of GNI) in Energy in 1980 to that in 1981?
Provide a succinct answer. 0.23. What is the ratio of the Cost (as % of GNI) of Water in 1980 to that in 1981?
Keep it short and to the point. 1.05. What is the ratio of the Cost (as % of GNI) in Coal in 1980 to that in 1982?
Offer a terse response. 0.7. What is the ratio of the Cost (as % of GNI) of Minerals in 1980 to that in 1982?
Your response must be concise. 4.08. What is the ratio of the Cost (as % of GNI) of Energy in 1980 to that in 1982?
Provide a short and direct response. 0.19. What is the ratio of the Cost (as % of GNI) of Water in 1980 to that in 1982?
Provide a short and direct response. 1.07. What is the ratio of the Cost (as % of GNI) of Coal in 1980 to that in 1983?
Ensure brevity in your answer.  0.58. What is the ratio of the Cost (as % of GNI) in Minerals in 1980 to that in 1983?
Provide a succinct answer. 3.34. What is the ratio of the Cost (as % of GNI) in Energy in 1980 to that in 1983?
Offer a very short reply. 0.63. What is the ratio of the Cost (as % of GNI) of Water in 1980 to that in 1983?
Ensure brevity in your answer.  2.11. What is the ratio of the Cost (as % of GNI) in Coal in 1980 to that in 1984?
Provide a short and direct response. 0.52. What is the ratio of the Cost (as % of GNI) of Minerals in 1980 to that in 1984?
Provide a succinct answer. 4.38. What is the ratio of the Cost (as % of GNI) in Energy in 1980 to that in 1984?
Your answer should be very brief. 6.06. What is the ratio of the Cost (as % of GNI) in Water in 1980 to that in 1984?
Your answer should be very brief. 4.55. What is the ratio of the Cost (as % of GNI) of Coal in 1981 to that in 1982?
Your response must be concise. 0.81. What is the ratio of the Cost (as % of GNI) in Minerals in 1981 to that in 1982?
Keep it short and to the point. 1.66. What is the ratio of the Cost (as % of GNI) in Energy in 1981 to that in 1982?
Your answer should be compact. 0.83. What is the ratio of the Cost (as % of GNI) in Water in 1981 to that in 1982?
Provide a short and direct response. 1.02. What is the ratio of the Cost (as % of GNI) of Coal in 1981 to that in 1983?
Your answer should be very brief. 0.67. What is the ratio of the Cost (as % of GNI) of Minerals in 1981 to that in 1983?
Keep it short and to the point. 1.36. What is the ratio of the Cost (as % of GNI) in Energy in 1981 to that in 1983?
Keep it short and to the point. 2.79. What is the ratio of the Cost (as % of GNI) of Water in 1981 to that in 1983?
Your response must be concise. 2.01. What is the ratio of the Cost (as % of GNI) in Coal in 1981 to that in 1984?
Offer a very short reply. 0.61. What is the ratio of the Cost (as % of GNI) in Minerals in 1981 to that in 1984?
Keep it short and to the point. 1.79. What is the ratio of the Cost (as % of GNI) of Energy in 1981 to that in 1984?
Ensure brevity in your answer.  26.91. What is the ratio of the Cost (as % of GNI) in Water in 1981 to that in 1984?
Your answer should be very brief. 4.34. What is the ratio of the Cost (as % of GNI) in Coal in 1982 to that in 1983?
Give a very brief answer. 0.83. What is the ratio of the Cost (as % of GNI) in Minerals in 1982 to that in 1983?
Offer a terse response. 0.82. What is the ratio of the Cost (as % of GNI) of Energy in 1982 to that in 1983?
Provide a short and direct response. 3.37. What is the ratio of the Cost (as % of GNI) of Water in 1982 to that in 1983?
Give a very brief answer. 1.98. What is the ratio of the Cost (as % of GNI) of Coal in 1982 to that in 1984?
Give a very brief answer. 0.75. What is the ratio of the Cost (as % of GNI) in Minerals in 1982 to that in 1984?
Ensure brevity in your answer.  1.07. What is the ratio of the Cost (as % of GNI) in Energy in 1982 to that in 1984?
Keep it short and to the point. 32.51. What is the ratio of the Cost (as % of GNI) of Water in 1982 to that in 1984?
Offer a terse response. 4.27. What is the ratio of the Cost (as % of GNI) in Coal in 1983 to that in 1984?
Give a very brief answer. 0.91. What is the ratio of the Cost (as % of GNI) of Minerals in 1983 to that in 1984?
Provide a short and direct response. 1.31. What is the ratio of the Cost (as % of GNI) in Energy in 1983 to that in 1984?
Your answer should be very brief. 9.64. What is the ratio of the Cost (as % of GNI) of Water in 1983 to that in 1984?
Offer a very short reply. 2.16. What is the difference between the highest and the second highest Cost (as % of GNI) of Coal?
Your answer should be very brief. 0.04. What is the difference between the highest and the second highest Cost (as % of GNI) of Minerals?
Ensure brevity in your answer.  0.01. What is the difference between the highest and the second highest Cost (as % of GNI) of Energy?
Offer a very short reply. 0. What is the difference between the highest and the second highest Cost (as % of GNI) of Water?
Provide a succinct answer. 0. What is the difference between the highest and the lowest Cost (as % of GNI) of Coal?
Provide a succinct answer. 0.23. What is the difference between the highest and the lowest Cost (as % of GNI) in Minerals?
Keep it short and to the point. 0.01. What is the difference between the highest and the lowest Cost (as % of GNI) of Energy?
Give a very brief answer. 0.01. What is the difference between the highest and the lowest Cost (as % of GNI) of Water?
Keep it short and to the point. 0.01. 